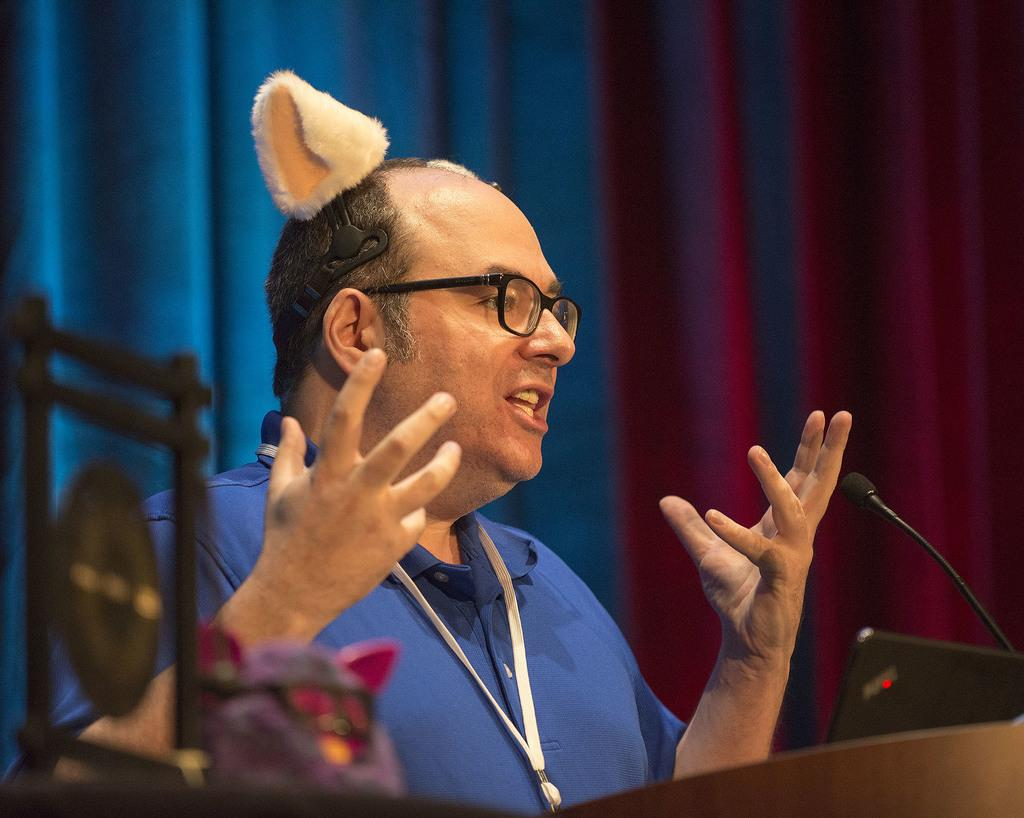What is the person in the image doing? The person in the image is speaking on a mic. What can be seen behind the person? There are curtains behind the person. What type of yam is being used as a prop in the image? There is no yam present in the image. What kind of powder is visible on the person's hands in the image? There is no powder visible on the person's hands in the image. 